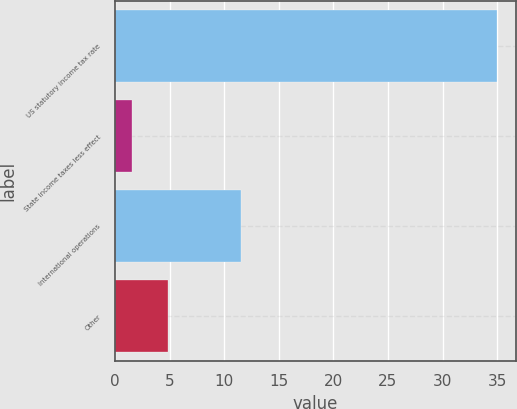Convert chart. <chart><loc_0><loc_0><loc_500><loc_500><bar_chart><fcel>US statutory income tax rate<fcel>State income taxes less effect<fcel>International operations<fcel>Other<nl><fcel>35<fcel>1.5<fcel>11.5<fcel>4.85<nl></chart> 